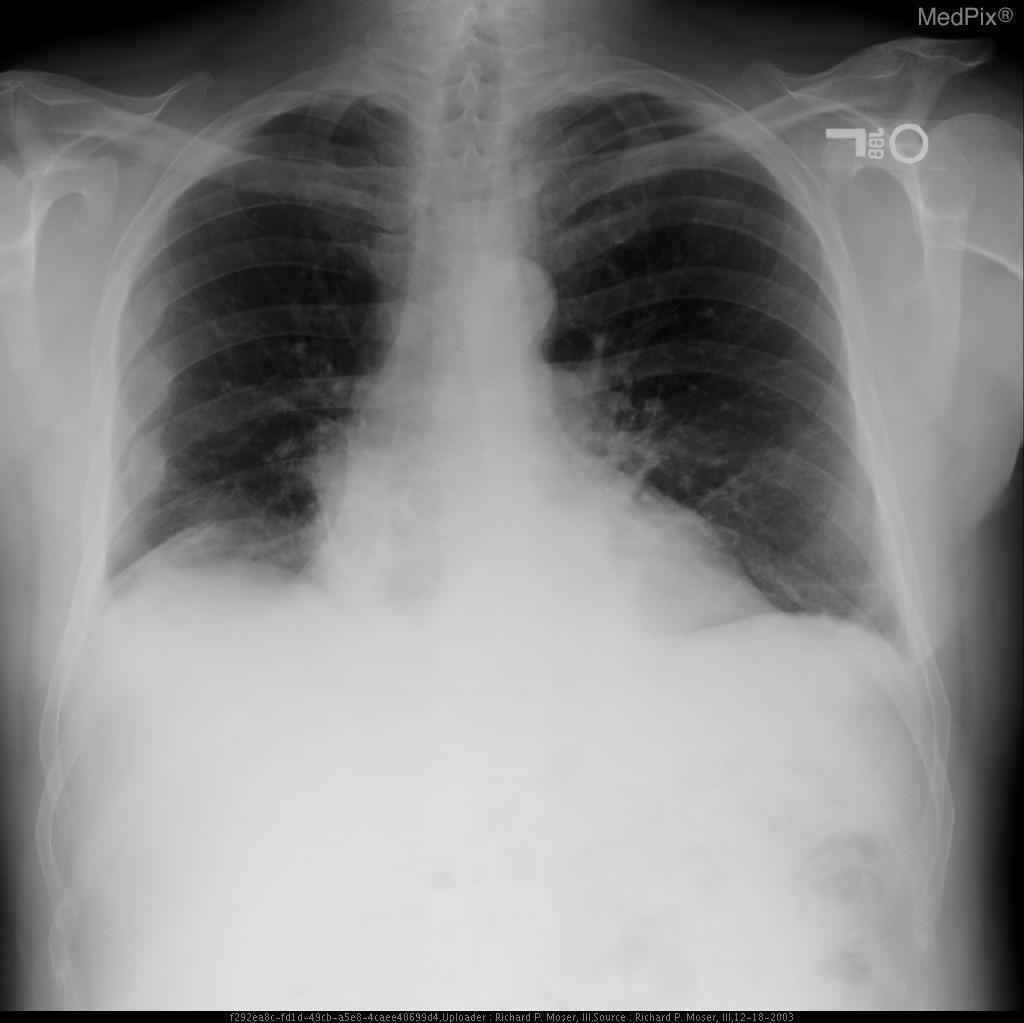Which lung has diffuse opacification?
Concise answer only. Right. What is happening to the right heart border?
Give a very brief answer. Partial silhouetting. How would you describe the r heart border?
Concise answer only. Partial silhouetting. Is the right costophrenic angle sharp?
Concise answer only. No. Is the right costophrenic angle easily visualized?
Concise answer only. No. What kind of image is this?
Concise answer only. Chest x-ray. What organ is primarily evaluated in this image?
Concise answer only. Lungs. Is this a lateral film?
Short answer required. No. Are the lungs normal?
Give a very brief answer. No. Is the chest x-ray normal?
Keep it brief. No. 